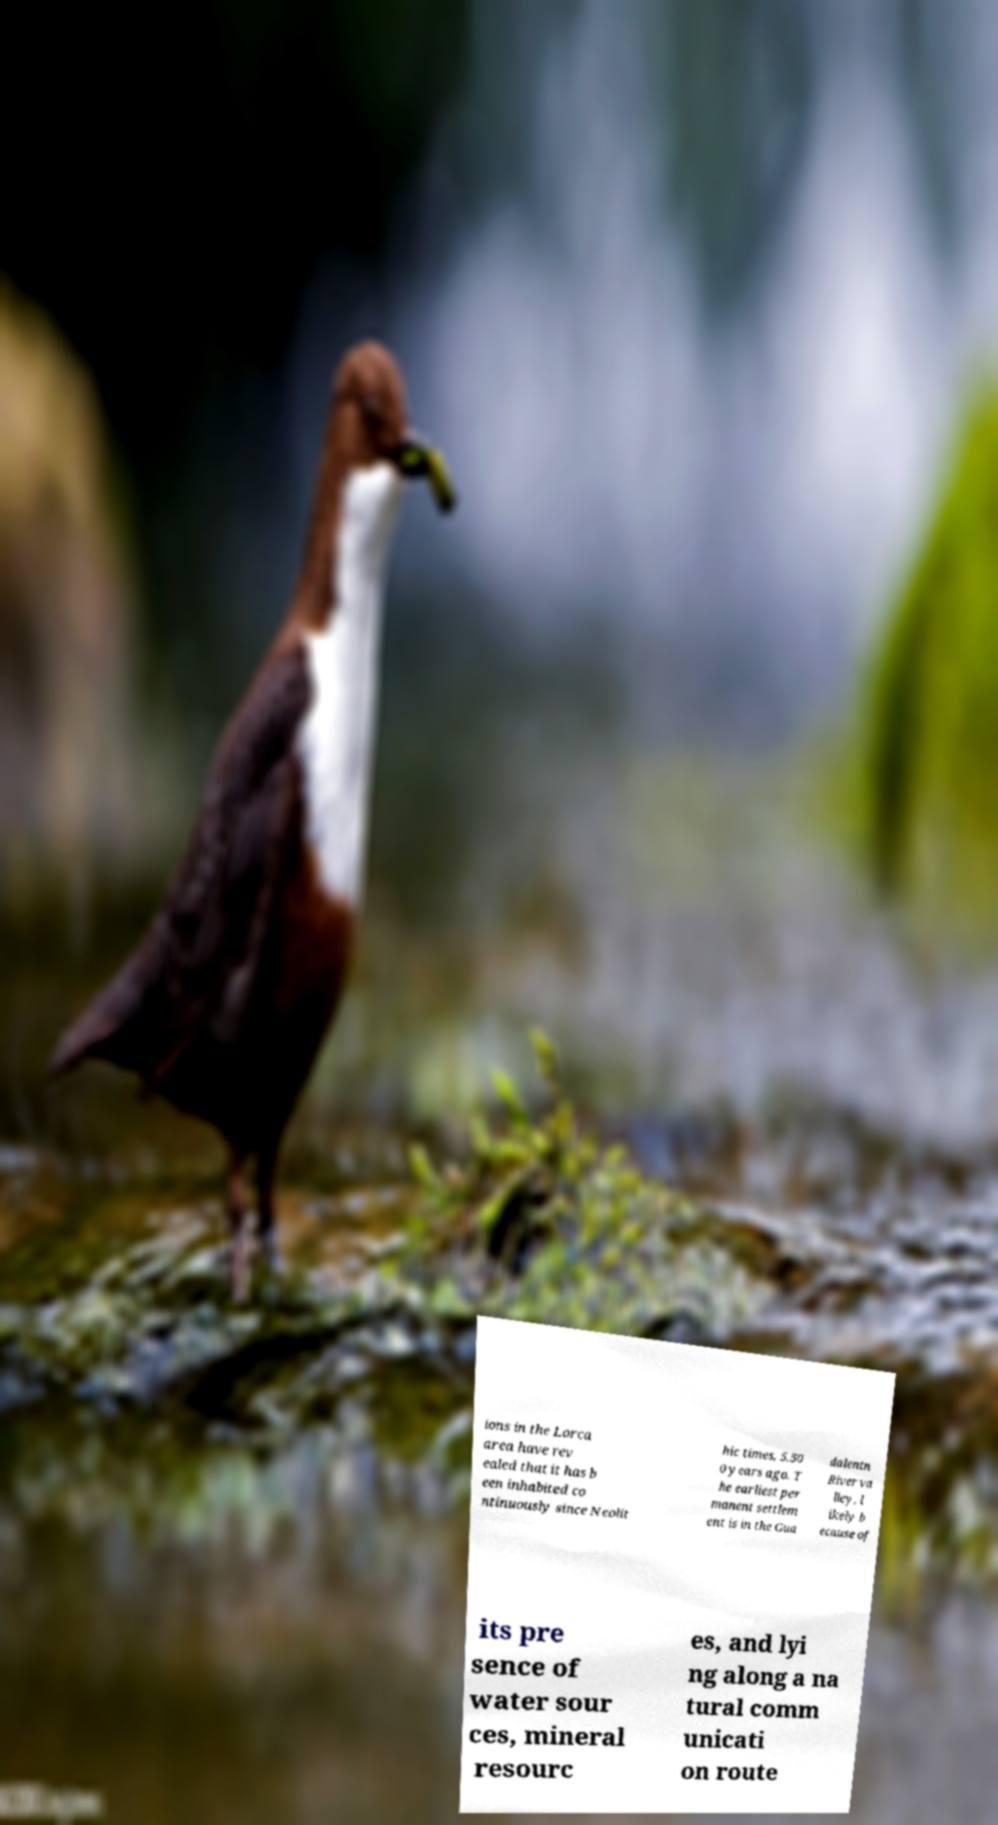Can you accurately transcribe the text from the provided image for me? ions in the Lorca area have rev ealed that it has b een inhabited co ntinuously since Neolit hic times, 5,50 0 years ago. T he earliest per manent settlem ent is in the Gua dalentn River va lley, l ikely b ecause of its pre sence of water sour ces, mineral resourc es, and lyi ng along a na tural comm unicati on route 